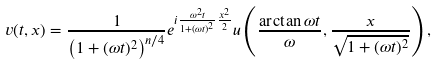<formula> <loc_0><loc_0><loc_500><loc_500>v ( t , x ) = \frac { 1 } { \left ( 1 + ( \omega t ) ^ { 2 } \right ) ^ { n / 4 } } e ^ { i \frac { \omega ^ { 2 } t } { 1 + ( \omega t ) ^ { 2 } } \frac { x ^ { 2 } } { 2 } } u \left ( \frac { \arctan \omega t } { \omega } , \frac { x } { \sqrt { 1 + ( \omega t ) ^ { 2 } } } \right ) ,</formula> 